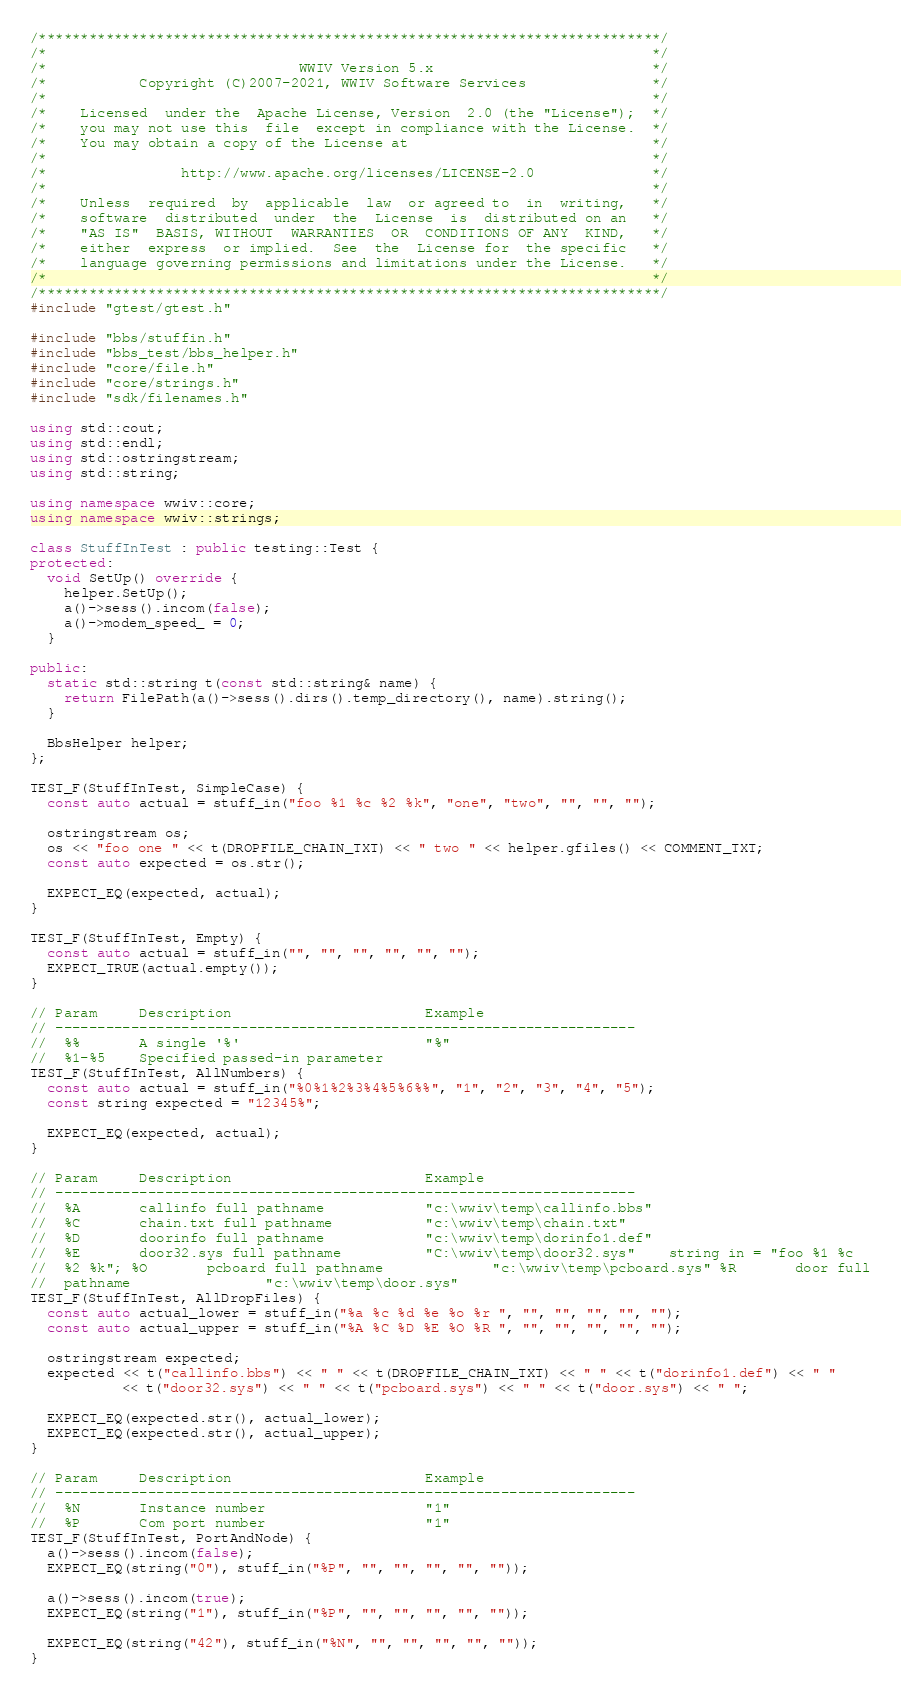Convert code to text. <code><loc_0><loc_0><loc_500><loc_500><_C++_>/**************************************************************************/
/*                                                                        */
/*                              WWIV Version 5.x                          */
/*           Copyright (C)2007-2021, WWIV Software Services               */
/*                                                                        */
/*    Licensed  under the  Apache License, Version  2.0 (the "License");  */
/*    you may not use this  file  except in compliance with the License.  */
/*    You may obtain a copy of the License at                             */
/*                                                                        */
/*                http://www.apache.org/licenses/LICENSE-2.0              */
/*                                                                        */
/*    Unless  required  by  applicable  law  or agreed to  in  writing,   */
/*    software  distributed  under  the  License  is  distributed on an   */
/*    "AS IS"  BASIS, WITHOUT  WARRANTIES  OR  CONDITIONS OF ANY  KIND,   */
/*    either  express  or implied.  See  the  License for  the specific   */
/*    language governing permissions and limitations under the License.   */
/*                                                                        */
/**************************************************************************/
#include "gtest/gtest.h"

#include "bbs/stuffin.h"
#include "bbs_test/bbs_helper.h"
#include "core/file.h"
#include "core/strings.h"
#include "sdk/filenames.h"

using std::cout;
using std::endl;
using std::ostringstream;
using std::string;

using namespace wwiv::core;
using namespace wwiv::strings;

class StuffInTest : public testing::Test {
protected:
  void SetUp() override {
    helper.SetUp();
    a()->sess().incom(false);
    a()->modem_speed_ = 0;
  }

public:
  static std::string t(const std::string& name) {
    return FilePath(a()->sess().dirs().temp_directory(), name).string();
  }

  BbsHelper helper;
};

TEST_F(StuffInTest, SimpleCase) {
  const auto actual = stuff_in("foo %1 %c %2 %k", "one", "two", "", "", "");

  ostringstream os;
  os << "foo one " << t(DROPFILE_CHAIN_TXT) << " two " << helper.gfiles() << COMMENT_TXT;
  const auto expected = os.str();

  EXPECT_EQ(expected, actual);
}

TEST_F(StuffInTest, Empty) {
  const auto actual = stuff_in("", "", "", "", "", "");
  EXPECT_TRUE(actual.empty());
}

// Param     Description                       Example
// ---------------------------------------------------------------------
//  %%       A single '%'                      "%"
//  %1-%5    Specified passed-in parameter
TEST_F(StuffInTest, AllNumbers) {
  const auto actual = stuff_in("%0%1%2%3%4%5%6%%", "1", "2", "3", "4", "5");
  const string expected = "12345%";

  EXPECT_EQ(expected, actual);
}

// Param     Description                       Example
// ---------------------------------------------------------------------
//  %A       callinfo full pathname            "c:\wwiv\temp\callinfo.bbs"
//  %C       chain.txt full pathname           "c:\wwiv\temp\chain.txt"
//  %D       doorinfo full pathname            "c:\wwiv\temp\dorinfo1.def"
//  %E       door32.sys full pathname          "C:\wwiv\temp\door32.sys"    string in = "foo %1 %c
//  %2 %k"; %O       pcboard full pathname             "c:\wwiv\temp\pcboard.sys" %R       door full
//  pathname                "c:\wwiv\temp\door.sys"
TEST_F(StuffInTest, AllDropFiles) {
  const auto actual_lower = stuff_in("%a %c %d %e %o %r ", "", "", "", "", "");
  const auto actual_upper = stuff_in("%A %C %D %E %O %R ", "", "", "", "", "");

  ostringstream expected;
  expected << t("callinfo.bbs") << " " << t(DROPFILE_CHAIN_TXT) << " " << t("dorinfo1.def") << " "
           << t("door32.sys") << " " << t("pcboard.sys") << " " << t("door.sys") << " ";

  EXPECT_EQ(expected.str(), actual_lower);
  EXPECT_EQ(expected.str(), actual_upper);
}

// Param     Description                       Example
// ---------------------------------------------------------------------
//  %N       Instance number                   "1"
//  %P       Com port number                   "1"
TEST_F(StuffInTest, PortAndNode) {
  a()->sess().incom(false);
  EXPECT_EQ(string("0"), stuff_in("%P", "", "", "", "", ""));

  a()->sess().incom(true);
  EXPECT_EQ(string("1"), stuff_in("%P", "", "", "", "", ""));

  EXPECT_EQ(string("42"), stuff_in("%N", "", "", "", "", ""));
}
</code> 